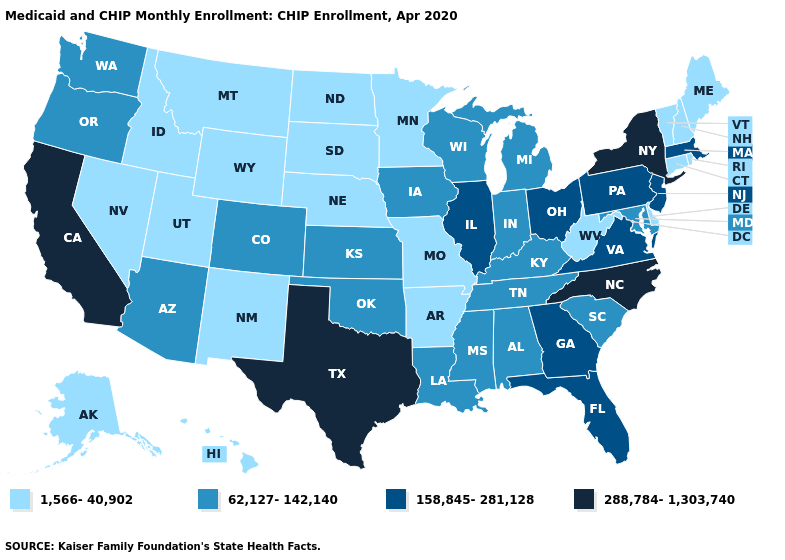Name the states that have a value in the range 288,784-1,303,740?
Give a very brief answer. California, New York, North Carolina, Texas. What is the value of West Virginia?
Be succinct. 1,566-40,902. Name the states that have a value in the range 158,845-281,128?
Give a very brief answer. Florida, Georgia, Illinois, Massachusetts, New Jersey, Ohio, Pennsylvania, Virginia. What is the highest value in the West ?
Answer briefly. 288,784-1,303,740. Does the first symbol in the legend represent the smallest category?
Answer briefly. Yes. Which states hav the highest value in the MidWest?
Write a very short answer. Illinois, Ohio. Among the states that border Vermont , which have the highest value?
Quick response, please. New York. What is the highest value in the USA?
Short answer required. 288,784-1,303,740. Name the states that have a value in the range 62,127-142,140?
Be succinct. Alabama, Arizona, Colorado, Indiana, Iowa, Kansas, Kentucky, Louisiana, Maryland, Michigan, Mississippi, Oklahoma, Oregon, South Carolina, Tennessee, Washington, Wisconsin. Among the states that border Tennessee , which have the lowest value?
Answer briefly. Arkansas, Missouri. What is the value of Montana?
Answer briefly. 1,566-40,902. What is the lowest value in states that border Wisconsin?
Give a very brief answer. 1,566-40,902. Does Connecticut have the same value as Illinois?
Short answer required. No. What is the highest value in states that border Iowa?
Write a very short answer. 158,845-281,128. What is the value of Rhode Island?
Concise answer only. 1,566-40,902. 